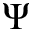<formula> <loc_0><loc_0><loc_500><loc_500>\Psi</formula> 